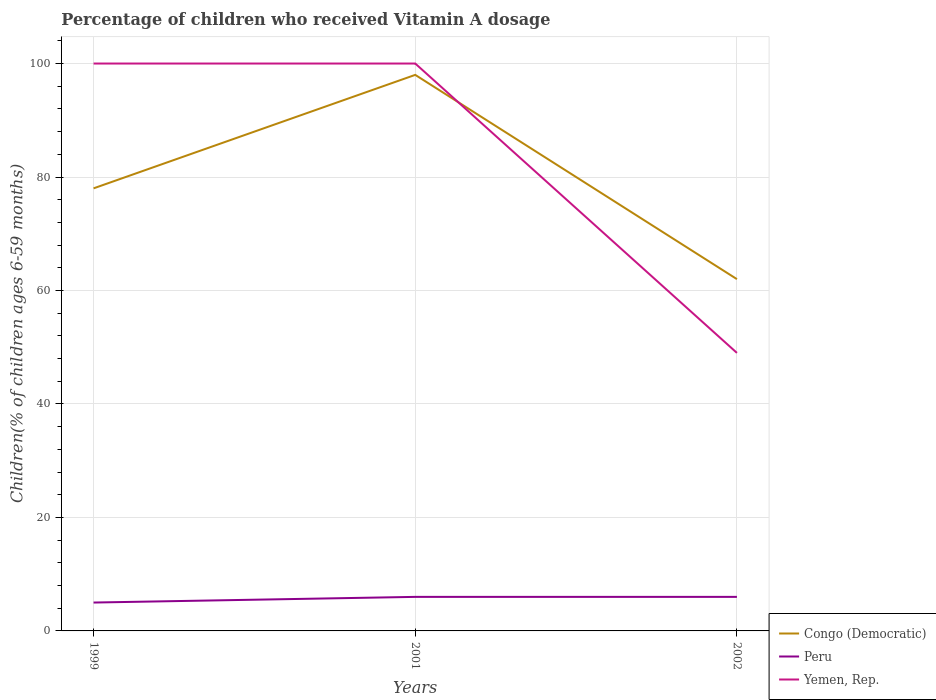Is the number of lines equal to the number of legend labels?
Keep it short and to the point. Yes. In which year was the percentage of children who received Vitamin A dosage in Peru maximum?
Give a very brief answer. 1999. What is the difference between the highest and the second highest percentage of children who received Vitamin A dosage in Congo (Democratic)?
Your answer should be compact. 36. How many lines are there?
Make the answer very short. 3. What is the difference between two consecutive major ticks on the Y-axis?
Your response must be concise. 20. Are the values on the major ticks of Y-axis written in scientific E-notation?
Your response must be concise. No. Does the graph contain grids?
Your answer should be compact. Yes. Where does the legend appear in the graph?
Keep it short and to the point. Bottom right. How many legend labels are there?
Provide a short and direct response. 3. What is the title of the graph?
Your answer should be compact. Percentage of children who received Vitamin A dosage. What is the label or title of the Y-axis?
Make the answer very short. Children(% of children ages 6-59 months). What is the Children(% of children ages 6-59 months) of Peru in 1999?
Keep it short and to the point. 5. What is the Children(% of children ages 6-59 months) of Congo (Democratic) in 2001?
Keep it short and to the point. 98. What is the Children(% of children ages 6-59 months) in Congo (Democratic) in 2002?
Your answer should be very brief. 62. What is the Children(% of children ages 6-59 months) of Peru in 2002?
Offer a terse response. 6. What is the Children(% of children ages 6-59 months) of Yemen, Rep. in 2002?
Offer a very short reply. 49. Across all years, what is the maximum Children(% of children ages 6-59 months) of Peru?
Make the answer very short. 6. Across all years, what is the maximum Children(% of children ages 6-59 months) in Yemen, Rep.?
Your answer should be very brief. 100. Across all years, what is the minimum Children(% of children ages 6-59 months) of Yemen, Rep.?
Your answer should be compact. 49. What is the total Children(% of children ages 6-59 months) in Congo (Democratic) in the graph?
Your answer should be compact. 238. What is the total Children(% of children ages 6-59 months) in Yemen, Rep. in the graph?
Offer a terse response. 249. What is the difference between the Children(% of children ages 6-59 months) of Peru in 1999 and that in 2001?
Your answer should be very brief. -1. What is the difference between the Children(% of children ages 6-59 months) of Yemen, Rep. in 1999 and that in 2001?
Ensure brevity in your answer.  0. What is the difference between the Children(% of children ages 6-59 months) of Peru in 1999 and that in 2002?
Give a very brief answer. -1. What is the difference between the Children(% of children ages 6-59 months) of Peru in 1999 and the Children(% of children ages 6-59 months) of Yemen, Rep. in 2001?
Provide a short and direct response. -95. What is the difference between the Children(% of children ages 6-59 months) in Congo (Democratic) in 1999 and the Children(% of children ages 6-59 months) in Peru in 2002?
Make the answer very short. 72. What is the difference between the Children(% of children ages 6-59 months) in Peru in 1999 and the Children(% of children ages 6-59 months) in Yemen, Rep. in 2002?
Make the answer very short. -44. What is the difference between the Children(% of children ages 6-59 months) of Congo (Democratic) in 2001 and the Children(% of children ages 6-59 months) of Peru in 2002?
Your response must be concise. 92. What is the difference between the Children(% of children ages 6-59 months) in Congo (Democratic) in 2001 and the Children(% of children ages 6-59 months) in Yemen, Rep. in 2002?
Make the answer very short. 49. What is the difference between the Children(% of children ages 6-59 months) in Peru in 2001 and the Children(% of children ages 6-59 months) in Yemen, Rep. in 2002?
Your response must be concise. -43. What is the average Children(% of children ages 6-59 months) in Congo (Democratic) per year?
Offer a terse response. 79.33. What is the average Children(% of children ages 6-59 months) in Peru per year?
Provide a short and direct response. 5.67. In the year 1999, what is the difference between the Children(% of children ages 6-59 months) in Congo (Democratic) and Children(% of children ages 6-59 months) in Yemen, Rep.?
Make the answer very short. -22. In the year 1999, what is the difference between the Children(% of children ages 6-59 months) in Peru and Children(% of children ages 6-59 months) in Yemen, Rep.?
Your answer should be compact. -95. In the year 2001, what is the difference between the Children(% of children ages 6-59 months) in Congo (Democratic) and Children(% of children ages 6-59 months) in Peru?
Your answer should be very brief. 92. In the year 2001, what is the difference between the Children(% of children ages 6-59 months) of Peru and Children(% of children ages 6-59 months) of Yemen, Rep.?
Your answer should be compact. -94. In the year 2002, what is the difference between the Children(% of children ages 6-59 months) in Congo (Democratic) and Children(% of children ages 6-59 months) in Peru?
Give a very brief answer. 56. In the year 2002, what is the difference between the Children(% of children ages 6-59 months) of Peru and Children(% of children ages 6-59 months) of Yemen, Rep.?
Your answer should be compact. -43. What is the ratio of the Children(% of children ages 6-59 months) of Congo (Democratic) in 1999 to that in 2001?
Make the answer very short. 0.8. What is the ratio of the Children(% of children ages 6-59 months) of Yemen, Rep. in 1999 to that in 2001?
Ensure brevity in your answer.  1. What is the ratio of the Children(% of children ages 6-59 months) in Congo (Democratic) in 1999 to that in 2002?
Offer a terse response. 1.26. What is the ratio of the Children(% of children ages 6-59 months) of Yemen, Rep. in 1999 to that in 2002?
Your answer should be very brief. 2.04. What is the ratio of the Children(% of children ages 6-59 months) in Congo (Democratic) in 2001 to that in 2002?
Make the answer very short. 1.58. What is the ratio of the Children(% of children ages 6-59 months) in Yemen, Rep. in 2001 to that in 2002?
Provide a succinct answer. 2.04. What is the difference between the highest and the second highest Children(% of children ages 6-59 months) in Congo (Democratic)?
Provide a short and direct response. 20. What is the difference between the highest and the second highest Children(% of children ages 6-59 months) of Peru?
Offer a terse response. 0. What is the difference between the highest and the lowest Children(% of children ages 6-59 months) of Yemen, Rep.?
Offer a very short reply. 51. 